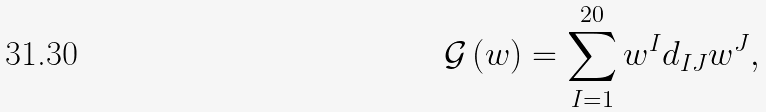<formula> <loc_0><loc_0><loc_500><loc_500>\mathcal { G } \left ( w \right ) = \sum _ { I = 1 } ^ { 2 0 } w ^ { I } d _ { I J } w ^ { J } ,</formula> 